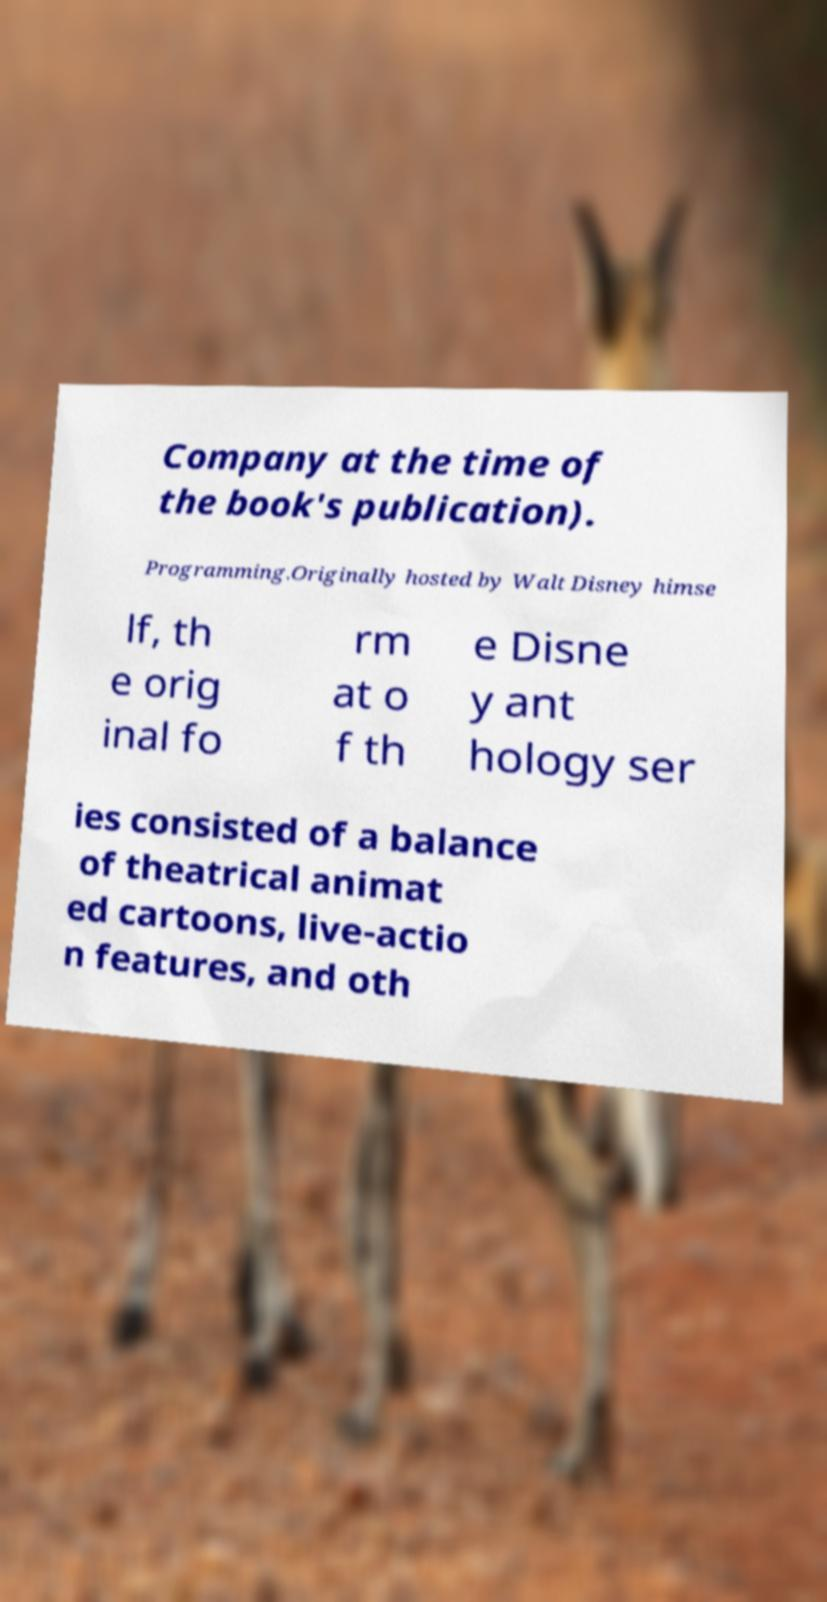Could you extract and type out the text from this image? Company at the time of the book's publication). Programming.Originally hosted by Walt Disney himse lf, th e orig inal fo rm at o f th e Disne y ant hology ser ies consisted of a balance of theatrical animat ed cartoons, live-actio n features, and oth 